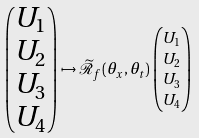Convert formula to latex. <formula><loc_0><loc_0><loc_500><loc_500>\begin{pmatrix} U _ { 1 } \\ U _ { 2 } \\ U _ { 3 } \\ U _ { 4 } \end{pmatrix} \mapsto \widetilde { \mathcal { R } } _ { f } ( \theta _ { x } , \theta _ { t } ) & \begin{pmatrix} U _ { 1 } \\ U _ { 2 } \\ U _ { 3 } \\ U _ { 4 } \end{pmatrix}</formula> 